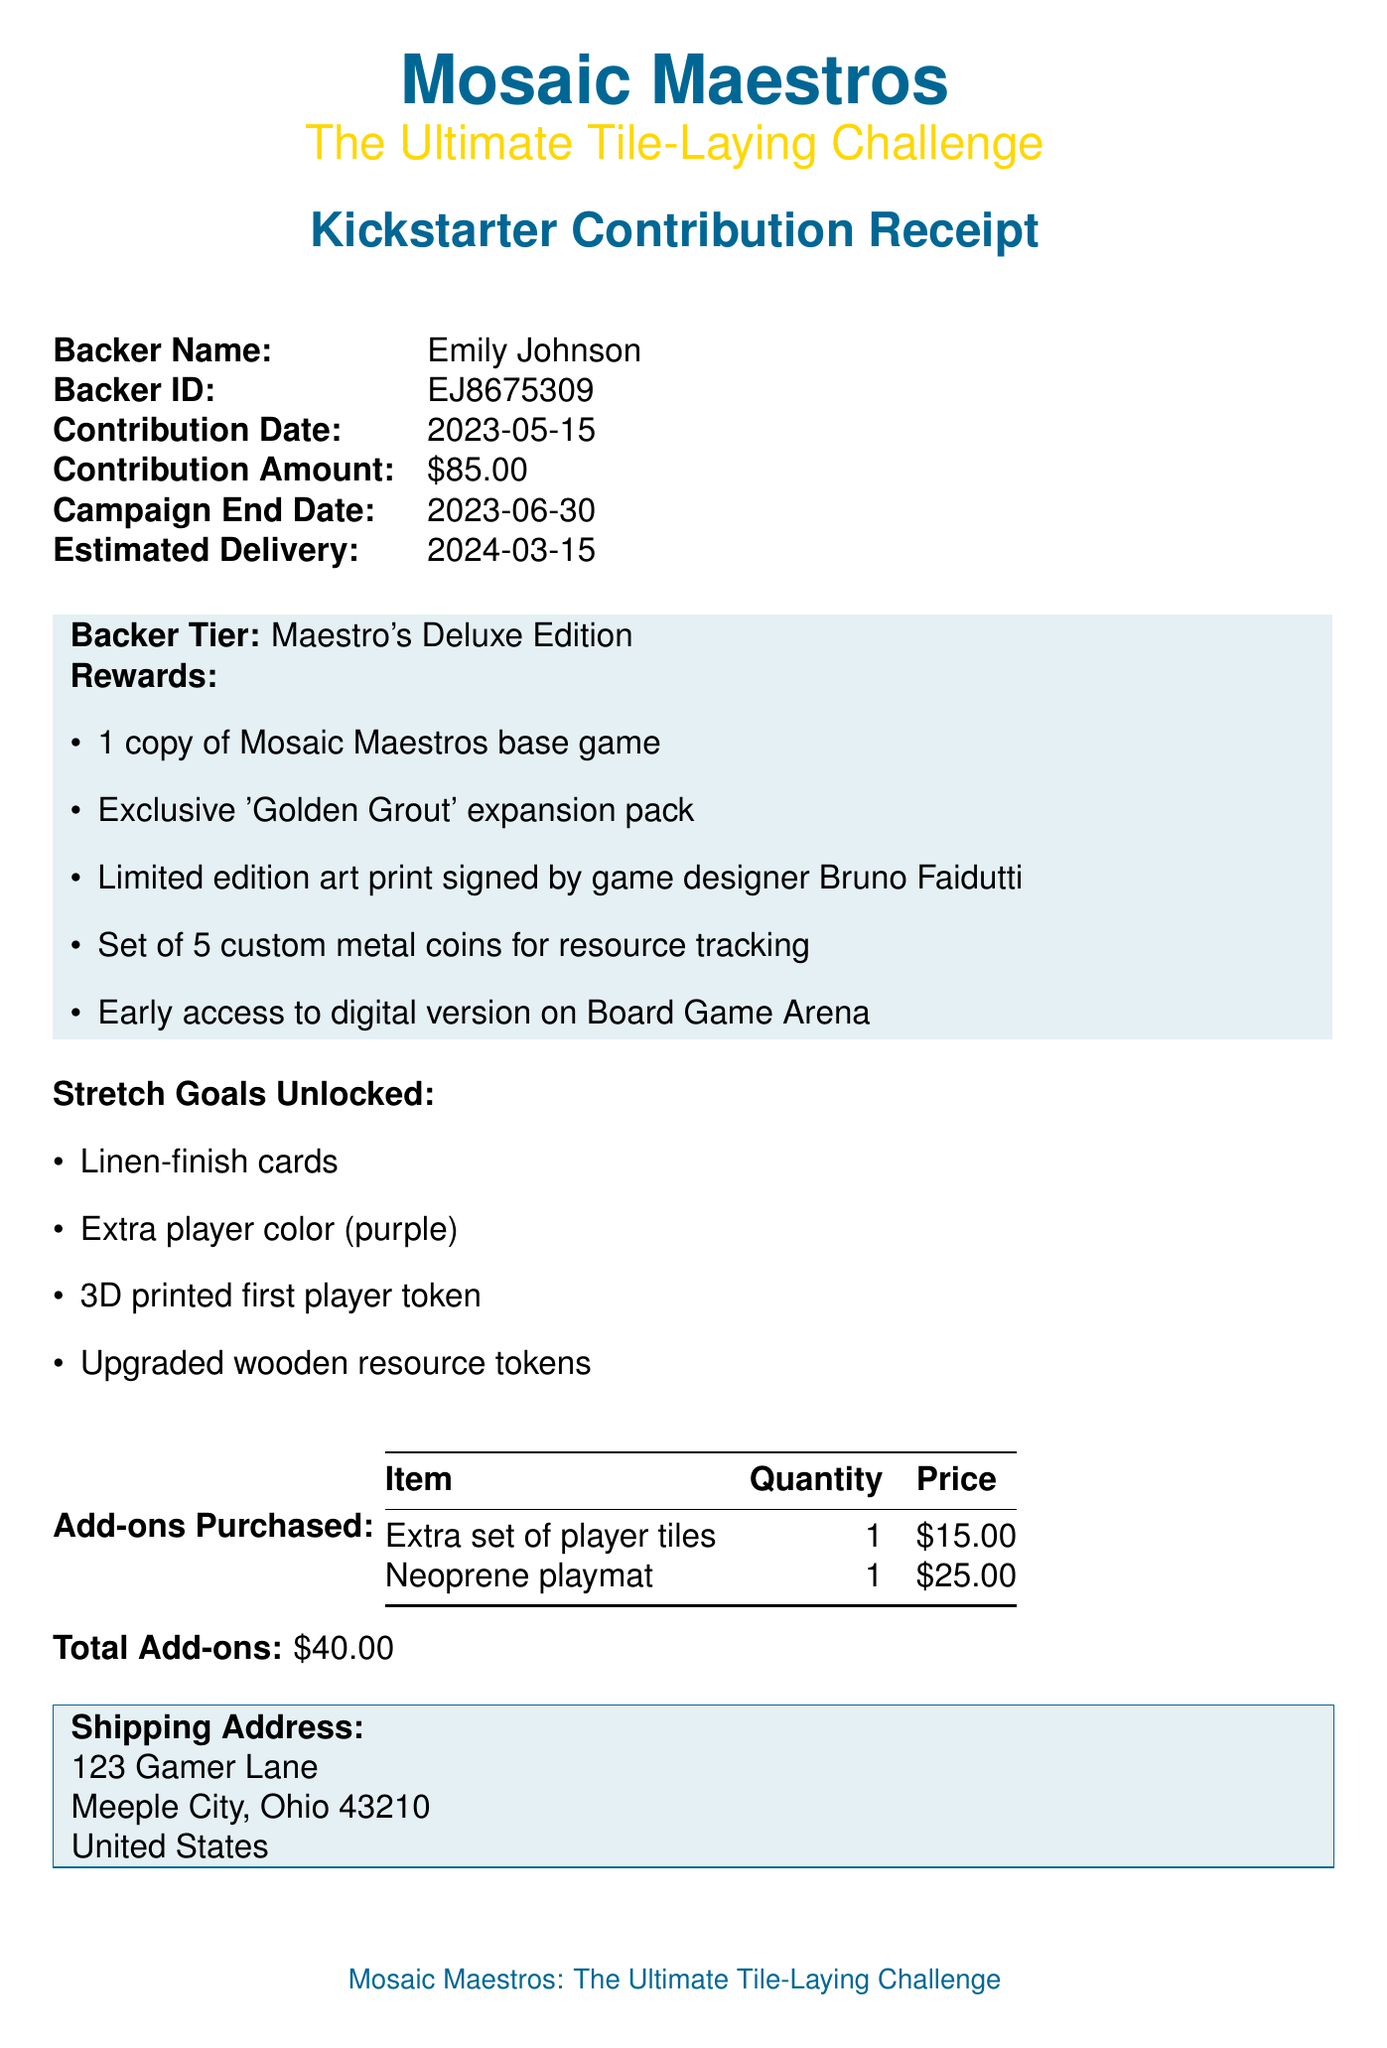What is the game title? The game title is specified at the top of the receipt.
Answer: Mosaic Maestros: The Ultimate Tile-Laying Challenge What is the backer name? The backer name appears prominently in the receipt details.
Answer: Emily Johnson What is the contribution date? The contribution date is mentioned in the details of the receipt.
Answer: 2023-05-15 What is the backer tier? The backer tier indicates the level of contribution and is listed in the receipt.
Answer: Maestro's Deluxe Edition What are the backer rewards? The backer rewards are listed in a bullet format under the backer tier section.
Answer: 1 copy of Mosaic Maestros base game, Exclusive 'Golden Grout' expansion pack, Limited edition art print signed by game designer Bruno Faidutti, Set of 5 custom metal coins for resource tracking, Early access to digital version on Board Game Arena What is the total amount for add-ons purchased? The total add-ons amount is provided under the add-ons purchased section.
Answer: $40.00 What is the shipping city? The shipping city is specified in the shipping address section of the receipt.
Answer: Meeple City What payment method was used? The payment method is clearly listed in the transaction details of the receipt.
Answer: Visa ending in 4321 What is the estimated delivery date? The estimated delivery date is mentioned in the contribution details section of the receipt.
Answer: 2024-03-15 Who is the campaign creator? The campaign creator is identified at the top of the receipt.
Answer: Tabletop Titans Games 